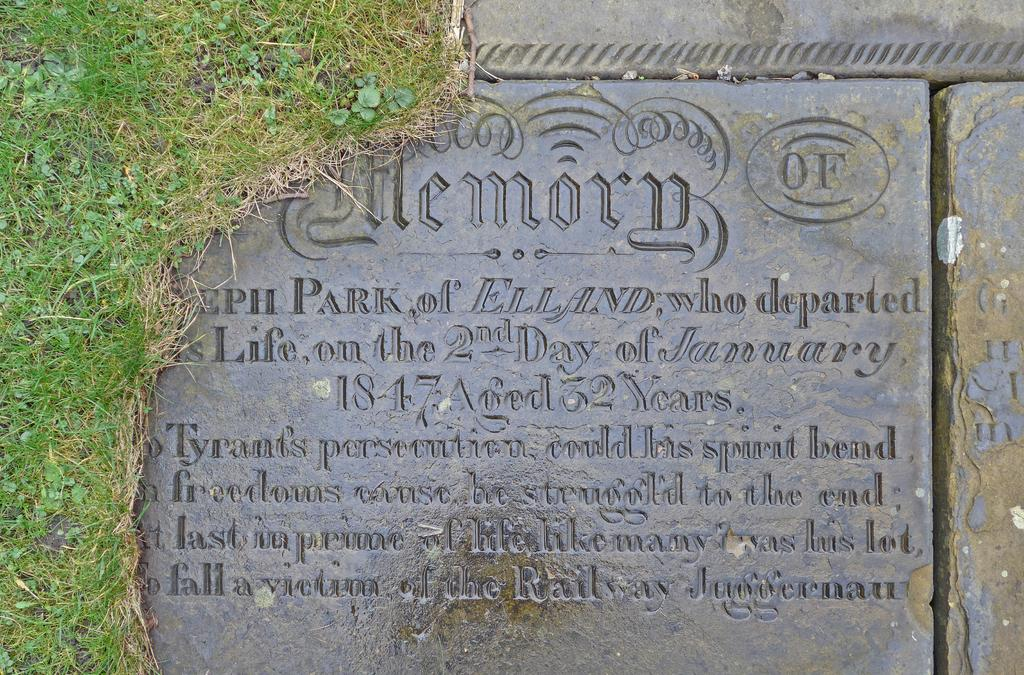What type of vegetation is present on the ground in the image? There is grass on the ground in the image. What is the color of the grass? The grass is green in color. What other object can be seen in the image besides the grass? There is a stone in the image. What is the color of the stone? The stone is black in color. What is written or engraved on the stone? There are words carved into the stone. How many ladybugs are crawling on the stone in the image? There are no ladybugs present in the image; it only features grass, a stone with carved words, and no mention of any insects. 